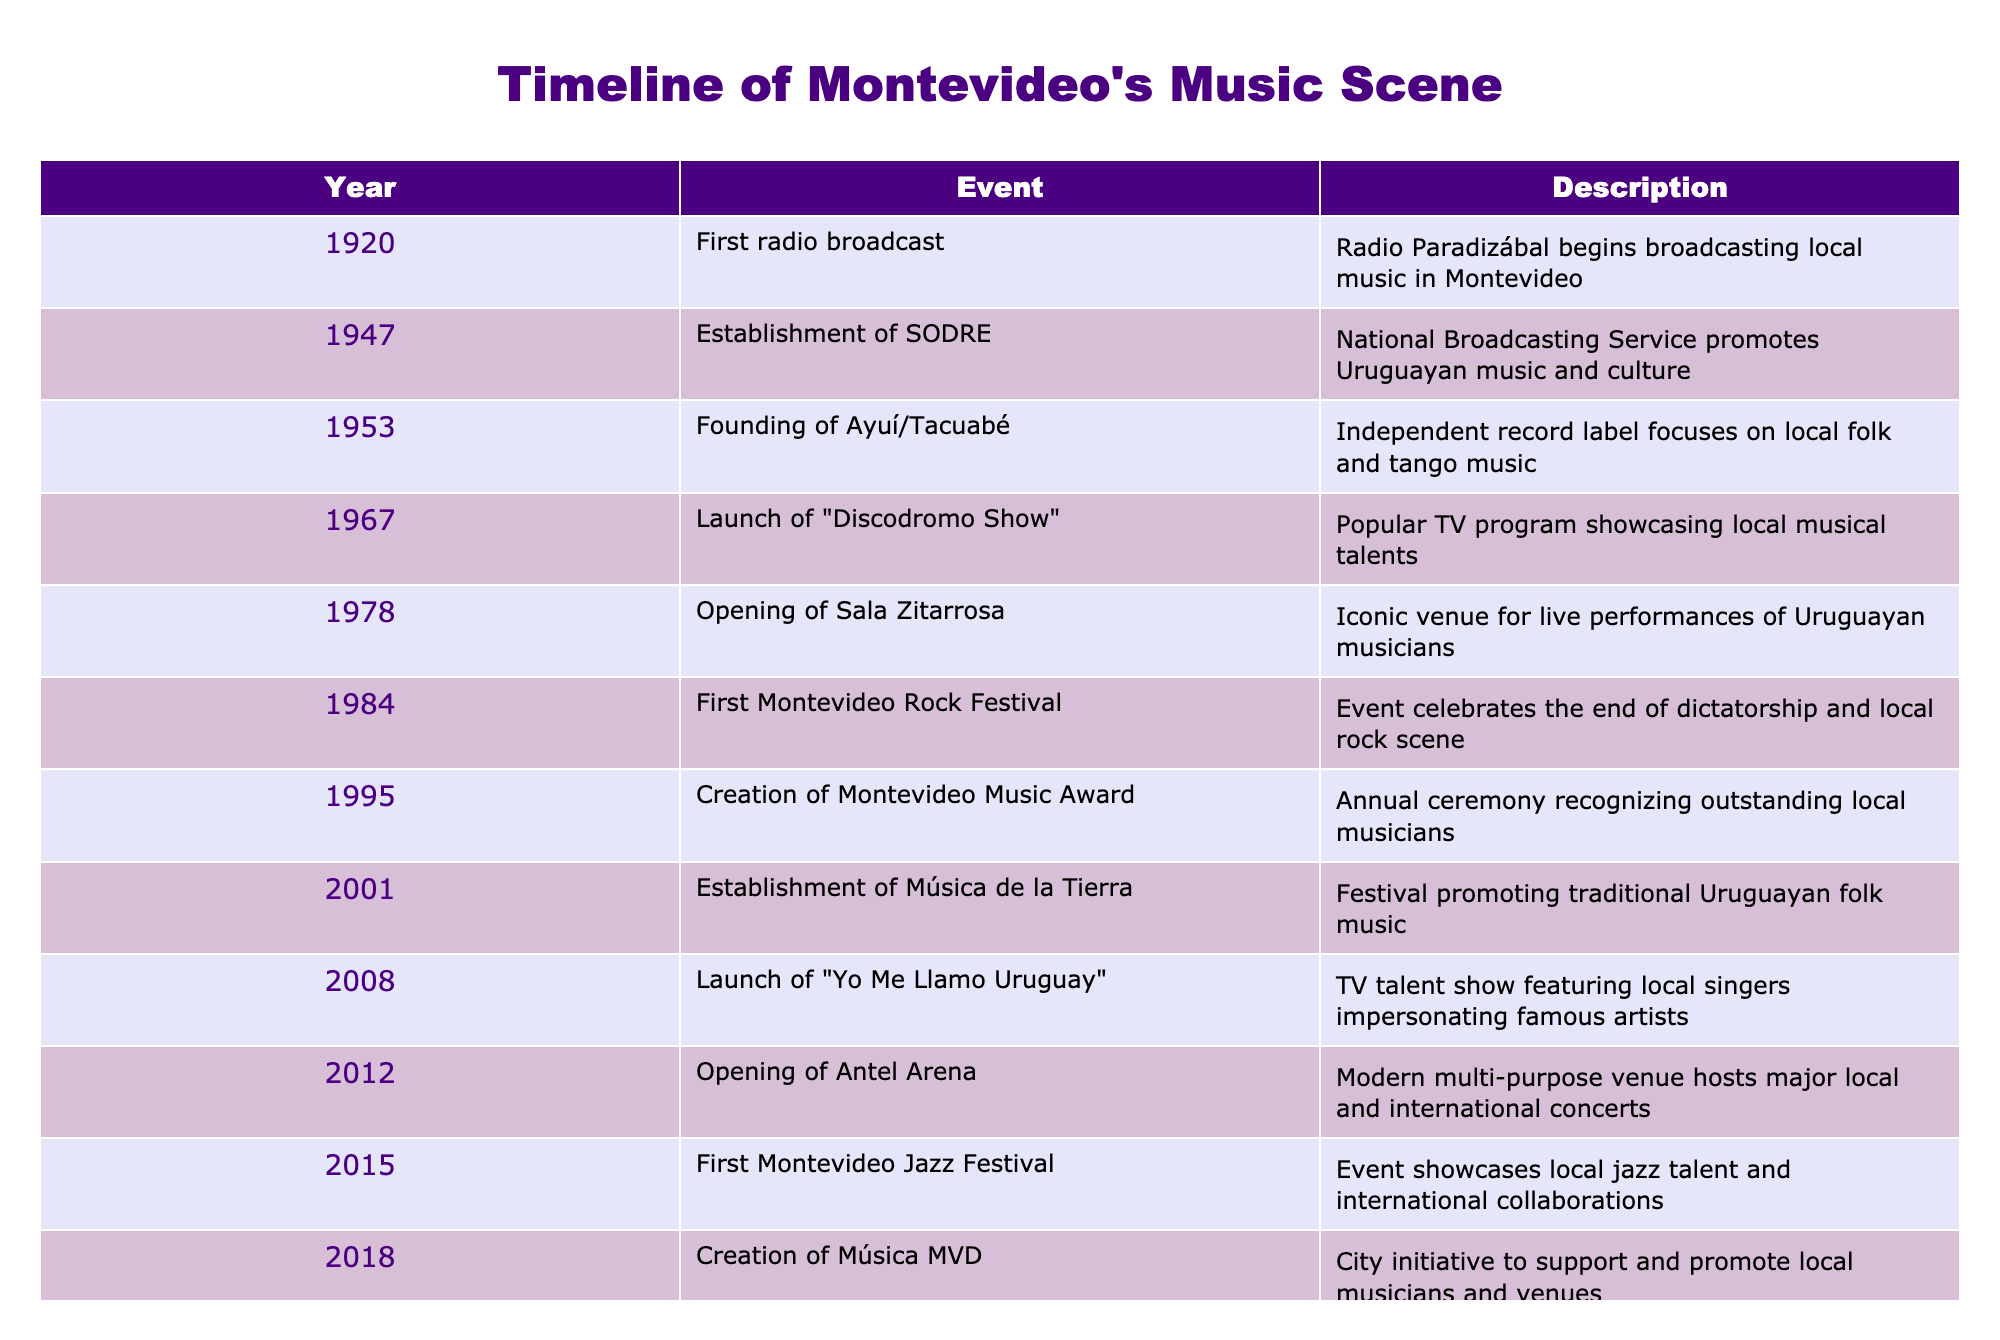What year did the first Montevideo Rock Festival take place? The table shows that the first Montevideo Rock Festival occurred in 1984. This can be found directly under the "Year" column when matching it with the corresponding event.
Answer: 1984 Which event marks the establishment of a venue specifically for live performances? The establishment of Sala Zitarrosa in 1978 is noted as an iconic venue for live performances of Uruguayan musicians. This information is easily located in the table.
Answer: Sala Zitarrosa in 1978 How many years are there between the opening of Antel Arena and the launch of "Yo Me Llamo Uruguay"? Antel Arena opened in 2012 and "Yo Me Llamo Uruguay" launched in 2008. Calculating the difference gives us 2012 - 2008 = 4 years. This can be understood by identifying the two events and their years in the table.
Answer: 4 years Did the creation of the Montevideo Music Award happen before the opening of Antel Arena? The Montevideo Music Award was created in 1995 and Antel Arena opened in 2012. Since 1995 is before 2012, the statement is true. This is determined by comparing their years in the table.
Answer: Yes What types of music are highlighted by the establishment of Música de la Tierra and its creation year? Música de la Tierra was established in 2001 and promotes traditional Uruguayan folk music. This information is gathered by locating the specific year and examining the description of the event in the table.
Answer: Traditional Uruguayan folk music in 2001 Between the first radio broadcast and the Montevideo Jazz Festival, which event showcases the longest interval of time? The first radio broadcast occurred in 1920 and the Montevideo Jazz Festival took place in 2015. The difference between the two years is 2015 - 1920 = 95 years. Thus, this event showcases the longest interval from the timeline of events provided in the table.
Answer: 95 years Which event occurred in 2020, and how did it adapt due to the pandemic? The event in 2020 is the Virtual Candombe Festival, which celebrated traditional Afro-Uruguayan music by going online due to the pandemic. This can be confirmed by looking for the year 2020 and reading the description alongside it.
Answer: Virtual Candombe Festival went online List all significant events related to local television programs after 2000. The events related to local television programs after 2000 are the launch of "Yo Me Llamo Uruguay" in 2008 and "Discodromo Show" in 1967. However, since the question pertains to events after 2000, only "Yo Me Llamo Uruguay" is relevant. To find these, I searched for years greater than 2000 and checked their descriptions.
Answer: Yo Me Llamo Uruguay in 2008 What is the significance of the 1984 event in the context of Uruguayan history? The first Montevideo Rock Festival in 1984 is significant as it celebrated the end of the dictatorship in Uruguay, highlighting its importance beyond music. This context can be inferred from the description provided in the table under that specific event.
Answer: Celebrating the end of the dictatorship 